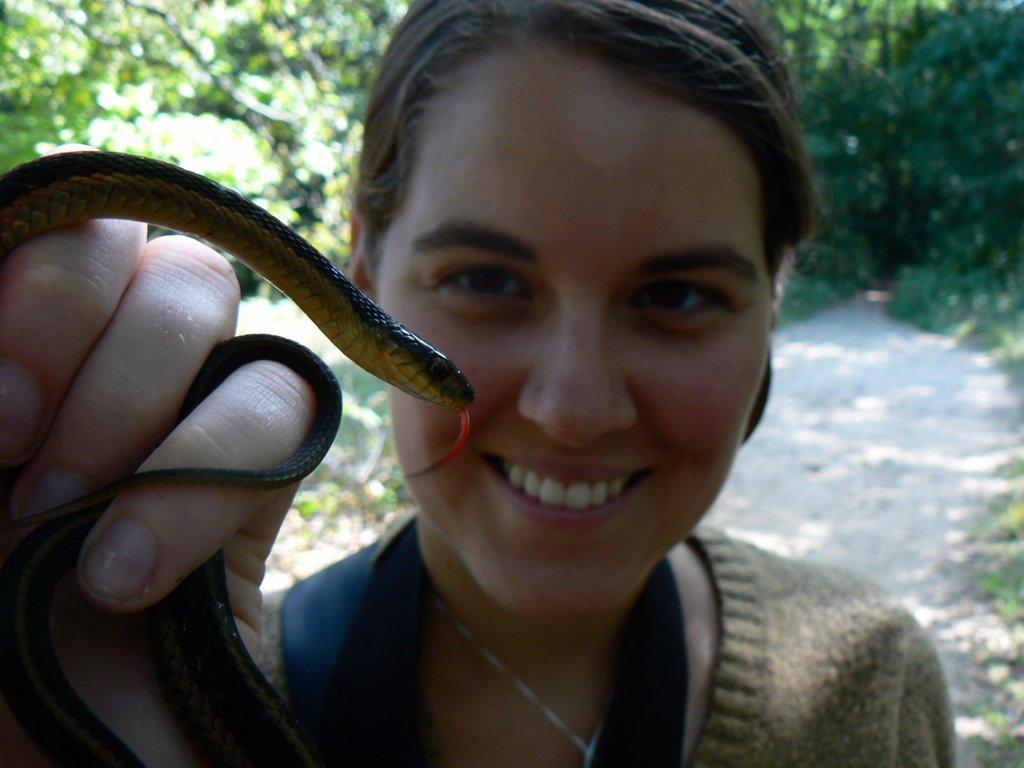Could you give a brief overview of what you see in this image? In this image in the front there is a woman holding a snake in his hand and smiling. In the background there are trees. 